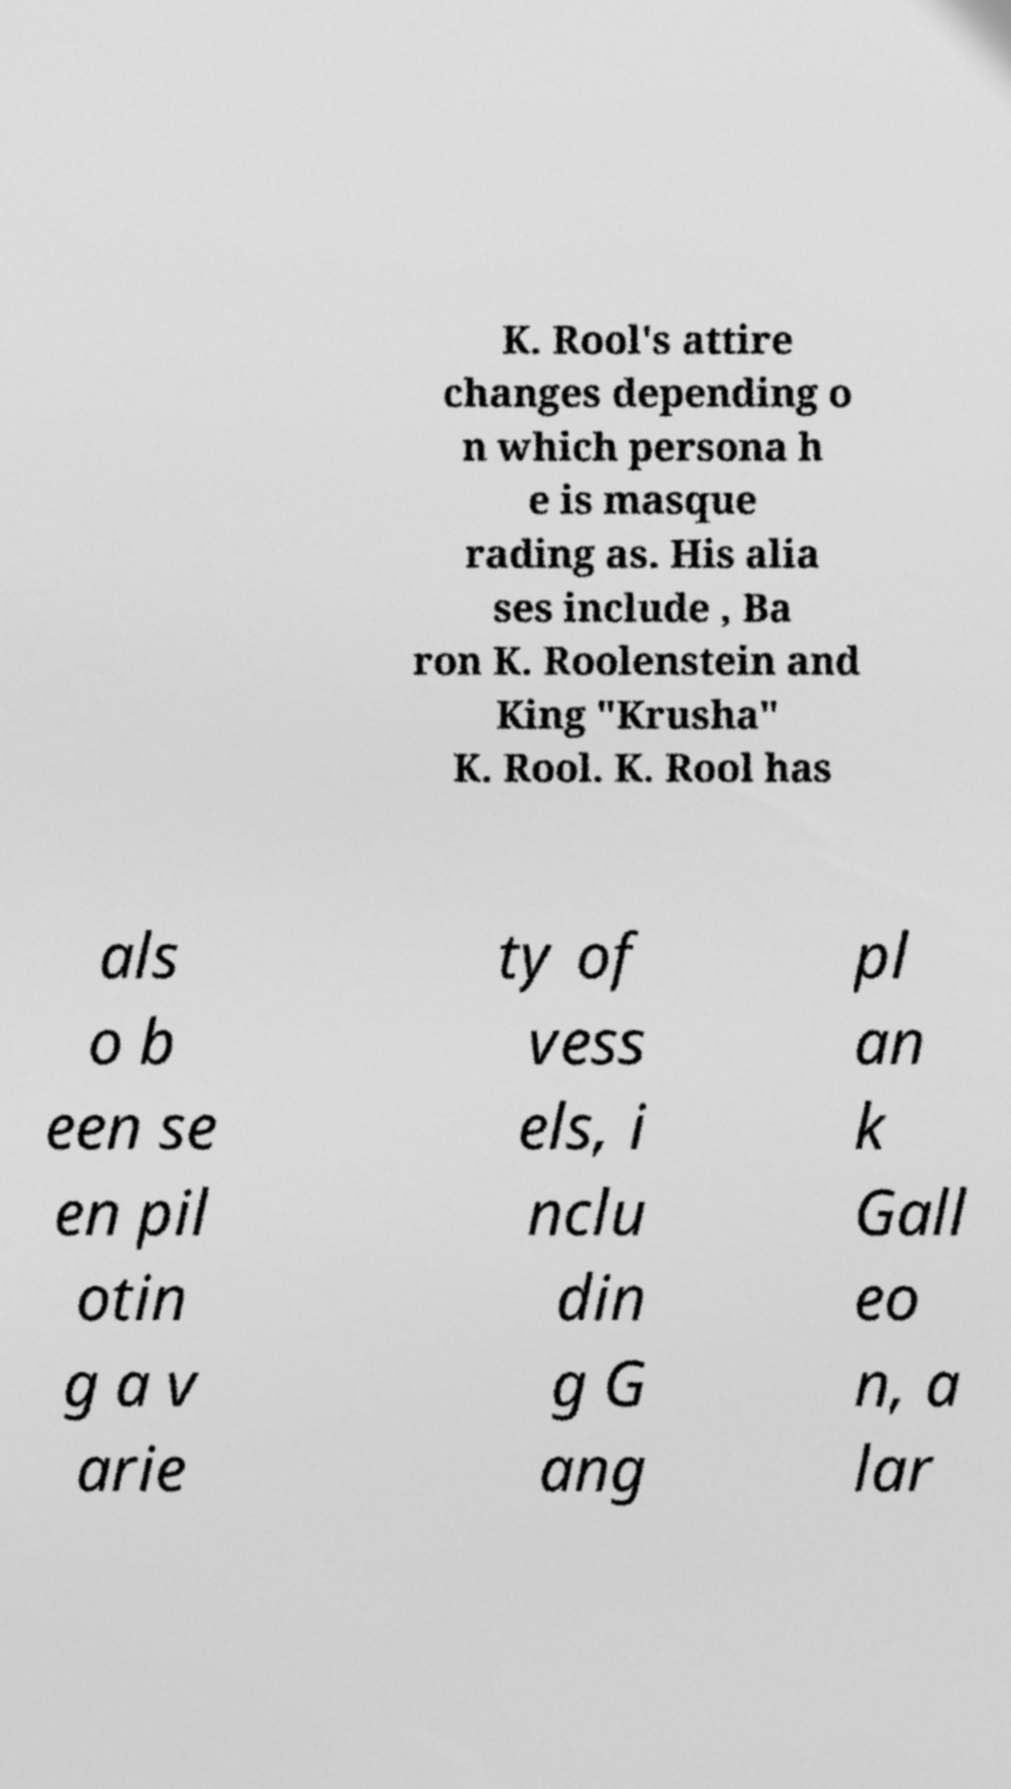Could you assist in decoding the text presented in this image and type it out clearly? K. Rool's attire changes depending o n which persona h e is masque rading as. His alia ses include , Ba ron K. Roolenstein and King "Krusha" K. Rool. K. Rool has als o b een se en pil otin g a v arie ty of vess els, i nclu din g G ang pl an k Gall eo n, a lar 